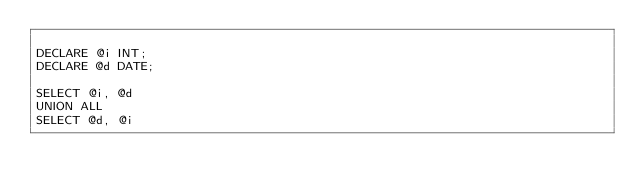<code> <loc_0><loc_0><loc_500><loc_500><_SQL_>
DECLARE @i INT;
DECLARE @d DATE;

SELECT @i, @d
UNION ALL
SELECT @d, @i</code> 